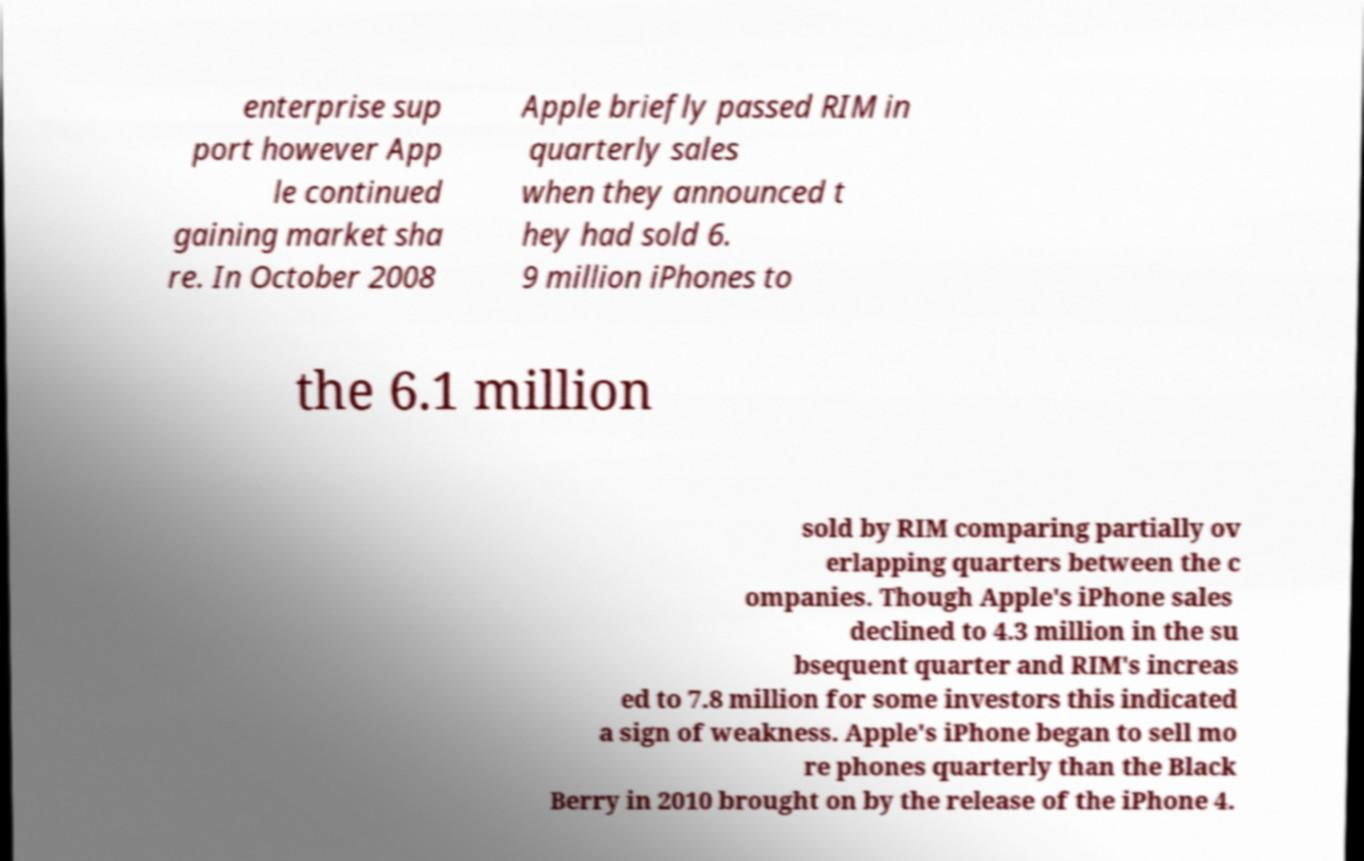Could you assist in decoding the text presented in this image and type it out clearly? enterprise sup port however App le continued gaining market sha re. In October 2008 Apple briefly passed RIM in quarterly sales when they announced t hey had sold 6. 9 million iPhones to the 6.1 million sold by RIM comparing partially ov erlapping quarters between the c ompanies. Though Apple's iPhone sales declined to 4.3 million in the su bsequent quarter and RIM's increas ed to 7.8 million for some investors this indicated a sign of weakness. Apple's iPhone began to sell mo re phones quarterly than the Black Berry in 2010 brought on by the release of the iPhone 4. 